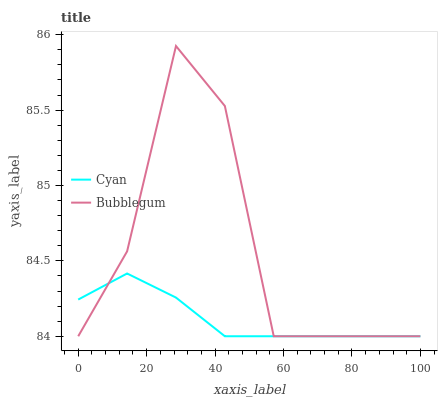Does Cyan have the minimum area under the curve?
Answer yes or no. Yes. Does Bubblegum have the maximum area under the curve?
Answer yes or no. Yes. Does Bubblegum have the minimum area under the curve?
Answer yes or no. No. Is Cyan the smoothest?
Answer yes or no. Yes. Is Bubblegum the roughest?
Answer yes or no. Yes. Is Bubblegum the smoothest?
Answer yes or no. No. Does Cyan have the lowest value?
Answer yes or no. Yes. Does Bubblegum have the highest value?
Answer yes or no. Yes. Does Bubblegum intersect Cyan?
Answer yes or no. Yes. Is Bubblegum less than Cyan?
Answer yes or no. No. Is Bubblegum greater than Cyan?
Answer yes or no. No. 